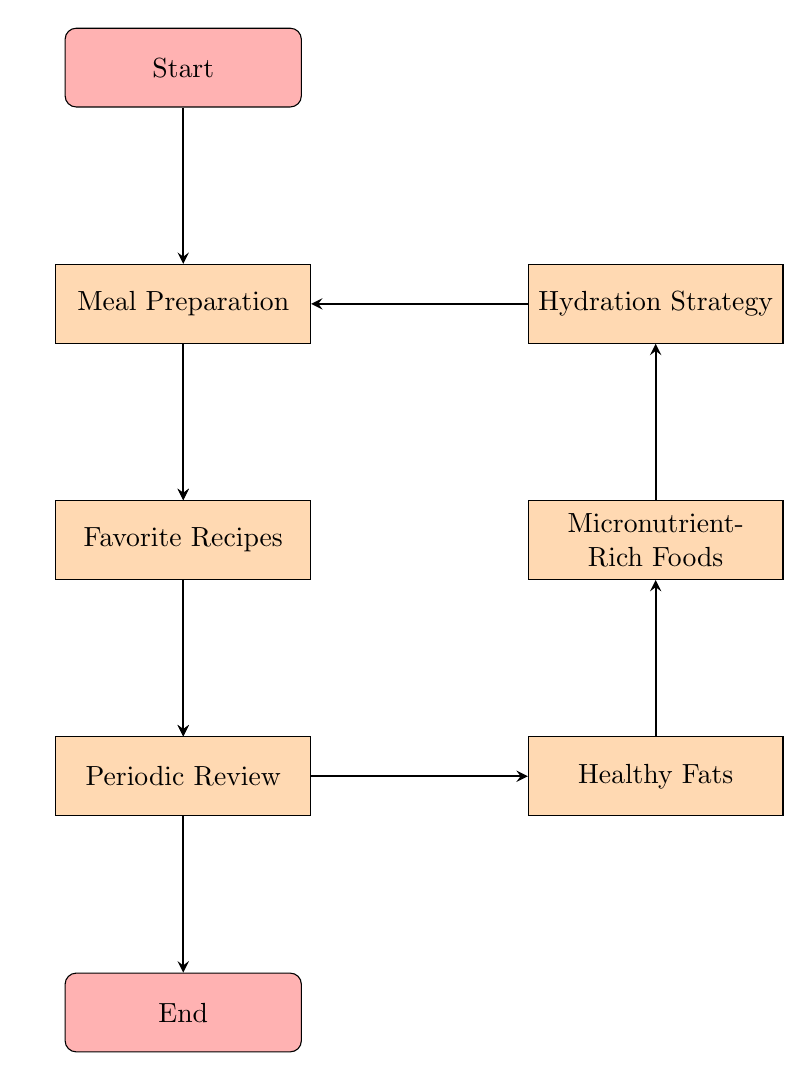What is the first step in the flow chart? The first step in the flow chart is labeled "Start." It is the initial node from which all subsequent steps are derived.
Answer: Start How many total nodes are there in the diagram? By counting each unique labeled node in the diagram, we see there are a total of 10 nodes: Start, Set Nutritional Goals, Ensure Protein Intake, Include Complex Carbohydrates, Healthy Fats, Micronutrient-Rich Foods, Hydration Strategy, Meal Preparation, Favorite Recipes, and Periodic Review.
Answer: 10 What is the last step before "End"? The last step before "End" is labeled "Periodic Review." This indicates the final process of reviewing the meal plan before concluding the plan's flow.
Answer: Periodic Review Which node follows "Meal Preparation"? The node that follows "Meal Preparation" is labeled "Favorite Recipes." This indicates that after planning meals, the next action involves sharing recipes.
Answer: Favorite Recipes What are two specific steps related to nutrient intake in this flow chart? The two specific steps related to nutrient intake are "Ensure Protein Intake" and "Include Complex Carbohydrates." These steps focus on incorporating protein sources and carbohydrates essential for energy and performance.
Answer: Ensure Protein Intake and Include Complex Carbohydrates Which two processes lead to hydration? The two processes that lead to hydration in the flow are "Micronutrient-Rich Foods" and "Hydration Strategy." First, optimizing micronutrients can assist hydration needs, followed by developing a specific hydration strategy.
Answer: Micronutrient-Rich Foods and Hydration Strategy If you reach "Healthy Fats," which node do you go to next? From "Healthy Fats," the next node is "Micronutrient-Rich Foods." This transition indicates that after adding healthy fats, the next emphasis is on incorporating micronutrient-rich foods.
Answer: Micronutrient-Rich Foods What does the "Set Nutritional Goals" step emphasize? The "Set Nutritional Goals" step emphasizes identifying calorie needs, macros, and micronutrients necessary for performance and recovery in athletes.
Answer: Identifying calorie needs, macros, and micronutrients for performance and recovery What is the goal of the "Periodic Review" process? The goal of the "Periodic Review" process is to regularly assess performance and energy levels to adjust the meal plan as needed to optimize nutrition for athletic demands.
Answer: Regularly assess performance, energy levels, and adjust the plan as needed 